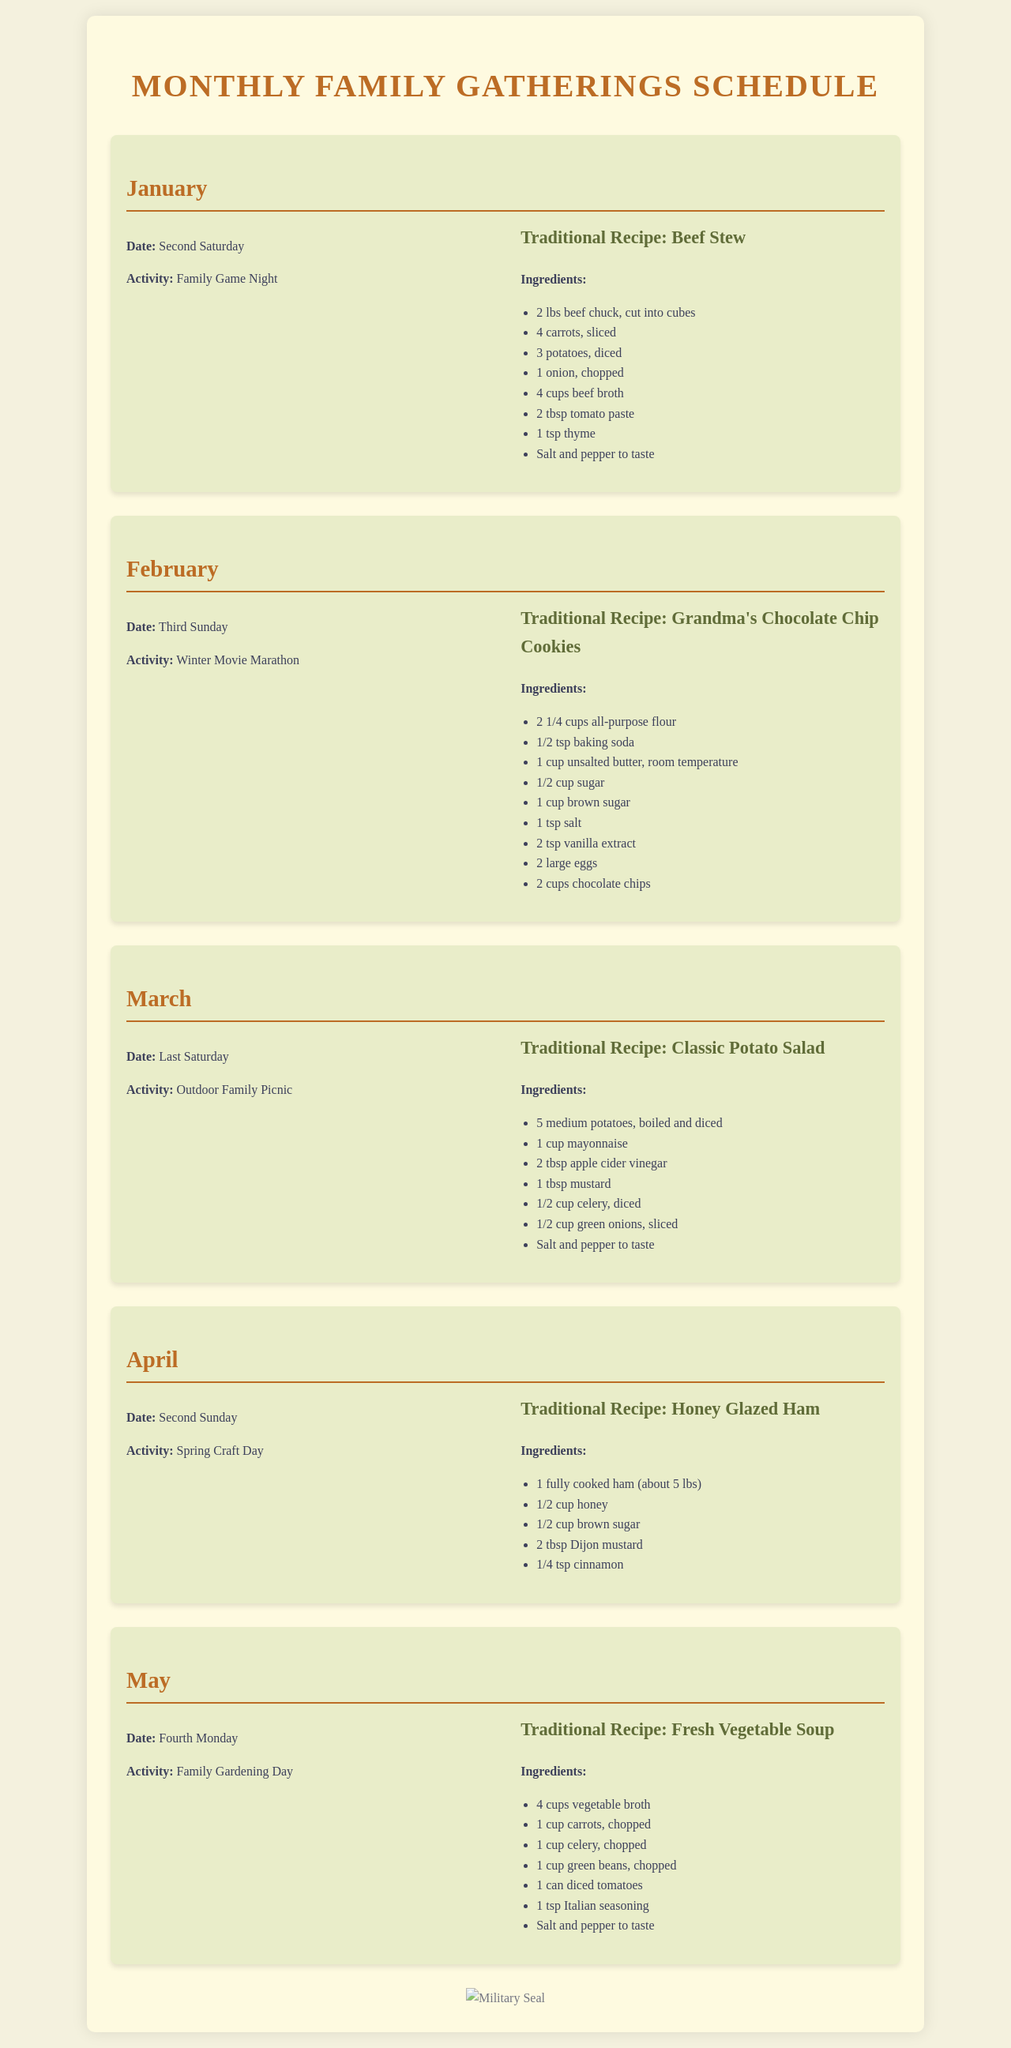What is the date for the January gathering? The document states that the gathering is on the second Saturday.
Answer: Second Saturday What activity is planned for February? According to the document, the activity for February is a Winter Movie Marathon.
Answer: Winter Movie Marathon What traditional recipe corresponds with March? The traditional recipe for March is Classic Potato Salad.
Answer: Classic Potato Salad How many ingredients are listed for Grandma's Chocolate Chip Cookies? The list of ingredients includes 9 items for Grandma's Chocolate Chip Cookies.
Answer: 9 What is the main ingredient in the Honey Glazed Ham recipe? The main ingredient in the Honey Glazed Ham recipe is a fully cooked ham.
Answer: Fully cooked ham Which month's gathering focuses on gardening? The document indicates that May's gathering focuses on Family Gardening Day.
Answer: May What is the date for the April gathering? The gathering in April takes place on the second Sunday.
Answer: Second Sunday What activity is scheduled for the last Saturday of March? The document specifies that the activity is an Outdoor Family Picnic.
Answer: Outdoor Family Picnic What is the total number of family gatherings scheduled from January to May? There are five family gatherings scheduled from January to May.
Answer: Five 